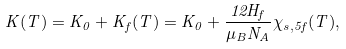<formula> <loc_0><loc_0><loc_500><loc_500>K ( T ) = K _ { 0 } + K _ { f } ( T ) = K _ { 0 } + \frac { 1 2 H _ { f } } { \mu _ { B } N _ { A } } \chi _ { s , 5 f } ( T ) ,</formula> 